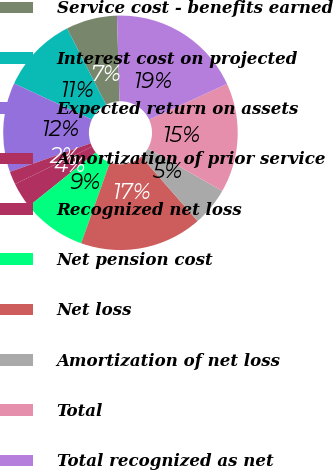<chart> <loc_0><loc_0><loc_500><loc_500><pie_chart><fcel>Service cost - benefits earned<fcel>Interest cost on projected<fcel>Expected return on assets<fcel>Amortization of prior service<fcel>Recognized net loss<fcel>Net pension cost<fcel>Net loss<fcel>Amortization of net loss<fcel>Total<fcel>Total recognized as net<nl><fcel>7.06%<fcel>10.56%<fcel>12.31%<fcel>1.8%<fcel>3.55%<fcel>8.81%<fcel>16.87%<fcel>5.3%<fcel>15.12%<fcel>18.62%<nl></chart> 